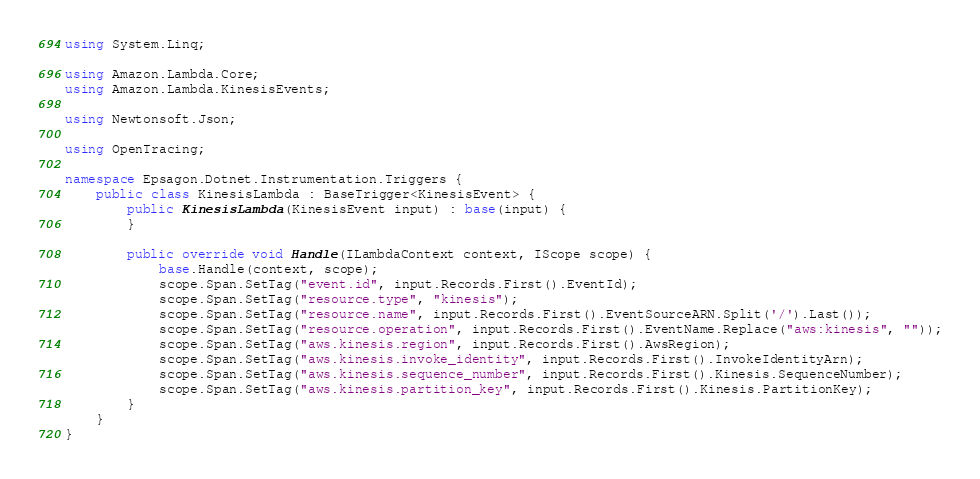<code> <loc_0><loc_0><loc_500><loc_500><_C#_>using System.Linq;

using Amazon.Lambda.Core;
using Amazon.Lambda.KinesisEvents;

using Newtonsoft.Json;

using OpenTracing;

namespace Epsagon.Dotnet.Instrumentation.Triggers {
    public class KinesisLambda : BaseTrigger<KinesisEvent> {
        public KinesisLambda(KinesisEvent input) : base(input) {
        }

        public override void Handle(ILambdaContext context, IScope scope) {
            base.Handle(context, scope);
            scope.Span.SetTag("event.id", input.Records.First().EventId);
            scope.Span.SetTag("resource.type", "kinesis");
            scope.Span.SetTag("resource.name", input.Records.First().EventSourceARN.Split('/').Last());
            scope.Span.SetTag("resource.operation", input.Records.First().EventName.Replace("aws:kinesis", ""));
            scope.Span.SetTag("aws.kinesis.region", input.Records.First().AwsRegion);
            scope.Span.SetTag("aws.kinesis.invoke_identity", input.Records.First().InvokeIdentityArn);
            scope.Span.SetTag("aws.kinesis.sequence_number", input.Records.First().Kinesis.SequenceNumber);
            scope.Span.SetTag("aws.kinesis.partition_key", input.Records.First().Kinesis.PartitionKey);
        }
    }
}
</code> 